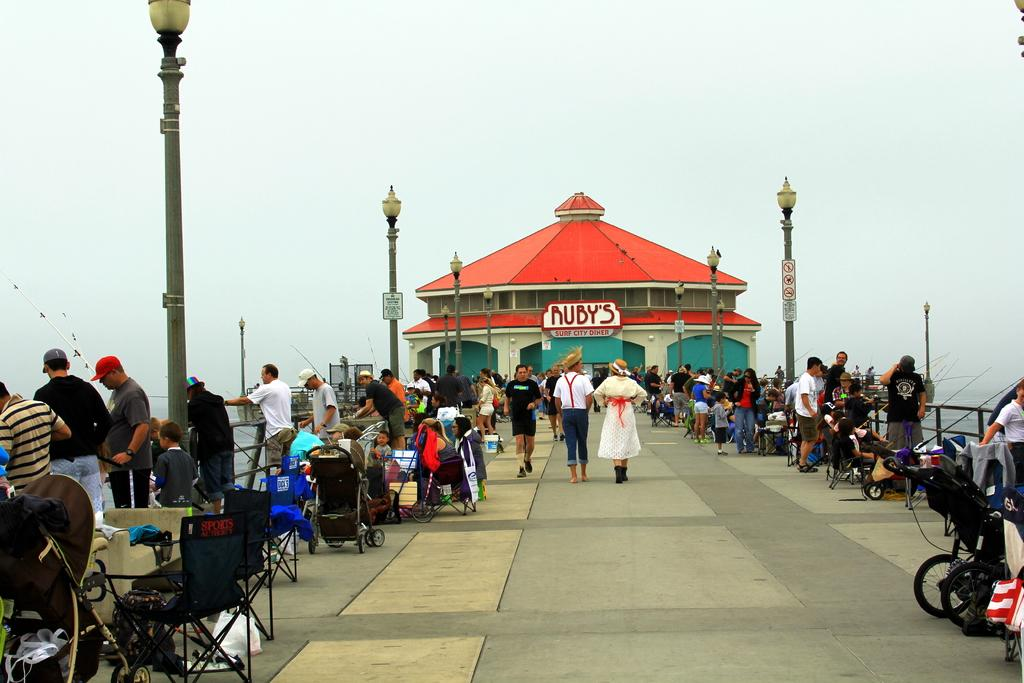What structure is visible in the image? There is a building in the image. What are the people in front of the building doing? Some people are fishing, some are walking, and some are sitting in chairs. Can you describe the activities of the people in the image? Some people are fishing, some are walking, and some are sitting in chairs. What type of chain can be seen hanging from the building in the image? There is no chain hanging from the building in the image. What is the people's fear in the image? There is no indication of fear in the image; people are engaged in various activities such as fishing, walking, and sitting. 